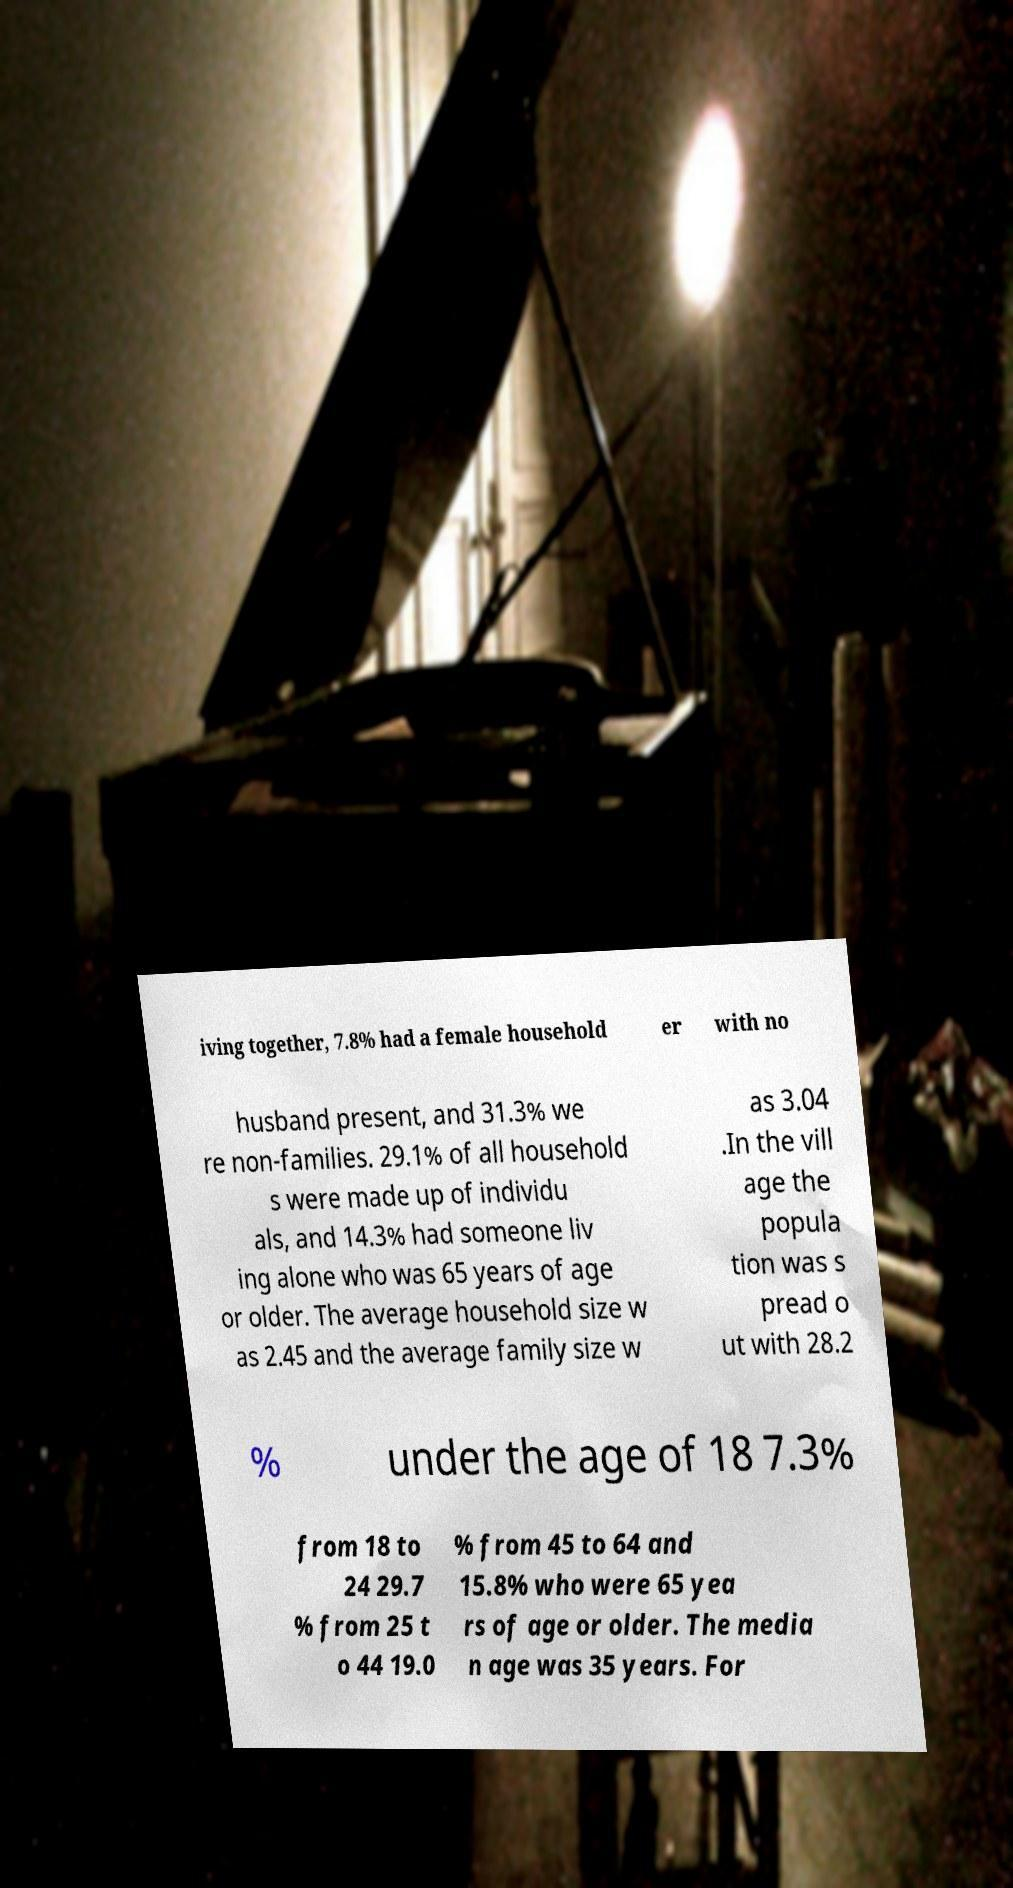Please identify and transcribe the text found in this image. iving together, 7.8% had a female household er with no husband present, and 31.3% we re non-families. 29.1% of all household s were made up of individu als, and 14.3% had someone liv ing alone who was 65 years of age or older. The average household size w as 2.45 and the average family size w as 3.04 .In the vill age the popula tion was s pread o ut with 28.2 % under the age of 18 7.3% from 18 to 24 29.7 % from 25 t o 44 19.0 % from 45 to 64 and 15.8% who were 65 yea rs of age or older. The media n age was 35 years. For 